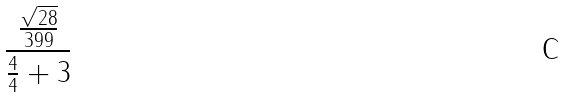<formula> <loc_0><loc_0><loc_500><loc_500>\frac { \frac { \sqrt { 2 8 } } { 3 9 9 } } { \frac { 4 } { 4 } + 3 }</formula> 